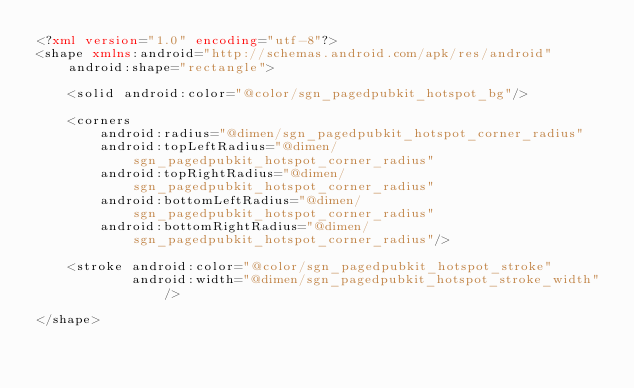Convert code to text. <code><loc_0><loc_0><loc_500><loc_500><_XML_><?xml version="1.0" encoding="utf-8"?>
<shape xmlns:android="http://schemas.android.com/apk/res/android"
    android:shape="rectangle">

    <solid android:color="@color/sgn_pagedpubkit_hotspot_bg"/>

    <corners
        android:radius="@dimen/sgn_pagedpubkit_hotspot_corner_radius"
        android:topLeftRadius="@dimen/sgn_pagedpubkit_hotspot_corner_radius"
        android:topRightRadius="@dimen/sgn_pagedpubkit_hotspot_corner_radius"
        android:bottomLeftRadius="@dimen/sgn_pagedpubkit_hotspot_corner_radius"
        android:bottomRightRadius="@dimen/sgn_pagedpubkit_hotspot_corner_radius"/>

    <stroke android:color="@color/sgn_pagedpubkit_hotspot_stroke"
            android:width="@dimen/sgn_pagedpubkit_hotspot_stroke_width"/>

</shape></code> 